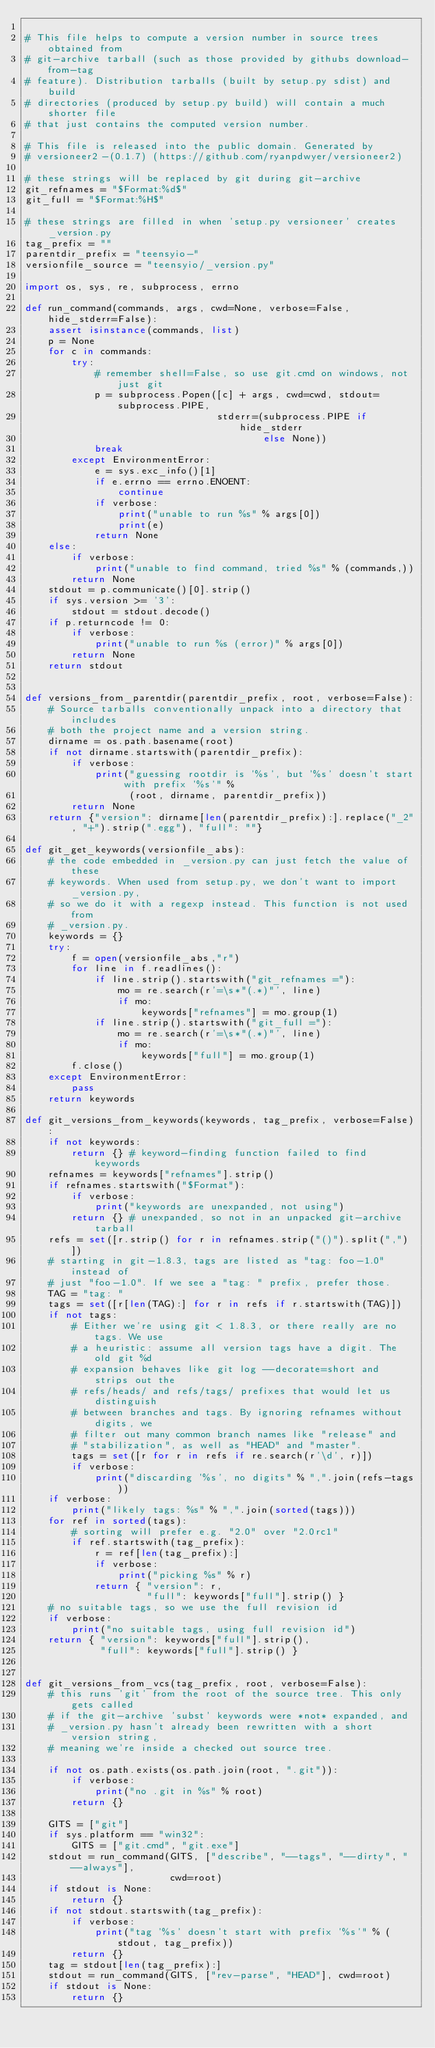<code> <loc_0><loc_0><loc_500><loc_500><_Python_>
# This file helps to compute a version number in source trees obtained from
# git-archive tarball (such as those provided by githubs download-from-tag
# feature). Distribution tarballs (built by setup.py sdist) and build
# directories (produced by setup.py build) will contain a much shorter file
# that just contains the computed version number.

# This file is released into the public domain. Generated by
# versioneer2-(0.1.7) (https://github.com/ryanpdwyer/versioneer2)

# these strings will be replaced by git during git-archive
git_refnames = "$Format:%d$"
git_full = "$Format:%H$"

# these strings are filled in when 'setup.py versioneer' creates _version.py
tag_prefix = ""
parentdir_prefix = "teensyio-"
versionfile_source = "teensyio/_version.py"

import os, sys, re, subprocess, errno

def run_command(commands, args, cwd=None, verbose=False, hide_stderr=False):
    assert isinstance(commands, list)
    p = None
    for c in commands:
        try:
            # remember shell=False, so use git.cmd on windows, not just git
            p = subprocess.Popen([c] + args, cwd=cwd, stdout=subprocess.PIPE,
                                 stderr=(subprocess.PIPE if hide_stderr
                                         else None))
            break
        except EnvironmentError:
            e = sys.exc_info()[1]
            if e.errno == errno.ENOENT:
                continue
            if verbose:
                print("unable to run %s" % args[0])
                print(e)
            return None
    else:
        if verbose:
            print("unable to find command, tried %s" % (commands,))
        return None
    stdout = p.communicate()[0].strip()
    if sys.version >= '3':
        stdout = stdout.decode()
    if p.returncode != 0:
        if verbose:
            print("unable to run %s (error)" % args[0])
        return None
    return stdout


def versions_from_parentdir(parentdir_prefix, root, verbose=False):
    # Source tarballs conventionally unpack into a directory that includes
    # both the project name and a version string.
    dirname = os.path.basename(root)
    if not dirname.startswith(parentdir_prefix):
        if verbose:
            print("guessing rootdir is '%s', but '%s' doesn't start with prefix '%s'" %
                  (root, dirname, parentdir_prefix))
        return None
    return {"version": dirname[len(parentdir_prefix):].replace("_2", "+").strip(".egg"), "full": ""}

def git_get_keywords(versionfile_abs):
    # the code embedded in _version.py can just fetch the value of these
    # keywords. When used from setup.py, we don't want to import _version.py,
    # so we do it with a regexp instead. This function is not used from
    # _version.py.
    keywords = {}
    try:
        f = open(versionfile_abs,"r")
        for line in f.readlines():
            if line.strip().startswith("git_refnames ="):
                mo = re.search(r'=\s*"(.*)"', line)
                if mo:
                    keywords["refnames"] = mo.group(1)
            if line.strip().startswith("git_full ="):
                mo = re.search(r'=\s*"(.*)"', line)
                if mo:
                    keywords["full"] = mo.group(1)
        f.close()
    except EnvironmentError:
        pass
    return keywords

def git_versions_from_keywords(keywords, tag_prefix, verbose=False):
    if not keywords:
        return {} # keyword-finding function failed to find keywords
    refnames = keywords["refnames"].strip()
    if refnames.startswith("$Format"):
        if verbose:
            print("keywords are unexpanded, not using")
        return {} # unexpanded, so not in an unpacked git-archive tarball
    refs = set([r.strip() for r in refnames.strip("()").split(",")])
    # starting in git-1.8.3, tags are listed as "tag: foo-1.0" instead of
    # just "foo-1.0". If we see a "tag: " prefix, prefer those.
    TAG = "tag: "
    tags = set([r[len(TAG):] for r in refs if r.startswith(TAG)])
    if not tags:
        # Either we're using git < 1.8.3, or there really are no tags. We use
        # a heuristic: assume all version tags have a digit. The old git %d
        # expansion behaves like git log --decorate=short and strips out the
        # refs/heads/ and refs/tags/ prefixes that would let us distinguish
        # between branches and tags. By ignoring refnames without digits, we
        # filter out many common branch names like "release" and
        # "stabilization", as well as "HEAD" and "master".
        tags = set([r for r in refs if re.search(r'\d', r)])
        if verbose:
            print("discarding '%s', no digits" % ",".join(refs-tags))
    if verbose:
        print("likely tags: %s" % ",".join(sorted(tags)))
    for ref in sorted(tags):
        # sorting will prefer e.g. "2.0" over "2.0rc1"
        if ref.startswith(tag_prefix):
            r = ref[len(tag_prefix):]
            if verbose:
                print("picking %s" % r)
            return { "version": r,
                     "full": keywords["full"].strip() }
    # no suitable tags, so we use the full revision id
    if verbose:
        print("no suitable tags, using full revision id")
    return { "version": keywords["full"].strip(),
             "full": keywords["full"].strip() }


def git_versions_from_vcs(tag_prefix, root, verbose=False):
    # this runs 'git' from the root of the source tree. This only gets called
    # if the git-archive 'subst' keywords were *not* expanded, and
    # _version.py hasn't already been rewritten with a short version string,
    # meaning we're inside a checked out source tree.

    if not os.path.exists(os.path.join(root, ".git")):
        if verbose:
            print("no .git in %s" % root)
        return {}

    GITS = ["git"]
    if sys.platform == "win32":
        GITS = ["git.cmd", "git.exe"]
    stdout = run_command(GITS, ["describe", "--tags", "--dirty", "--always"],
                         cwd=root)
    if stdout is None:
        return {}
    if not stdout.startswith(tag_prefix):
        if verbose:
            print("tag '%s' doesn't start with prefix '%s'" % (stdout, tag_prefix))
        return {}
    tag = stdout[len(tag_prefix):]
    stdout = run_command(GITS, ["rev-parse", "HEAD"], cwd=root)
    if stdout is None:
        return {}</code> 